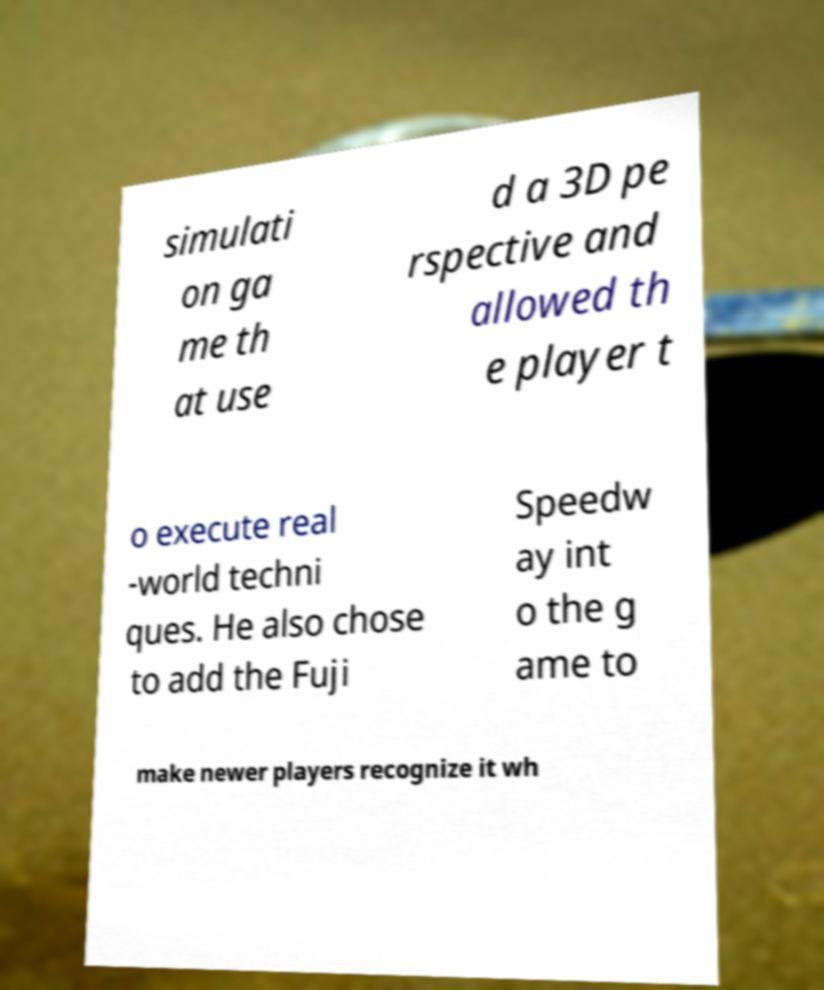Could you assist in decoding the text presented in this image and type it out clearly? simulati on ga me th at use d a 3D pe rspective and allowed th e player t o execute real -world techni ques. He also chose to add the Fuji Speedw ay int o the g ame to make newer players recognize it wh 